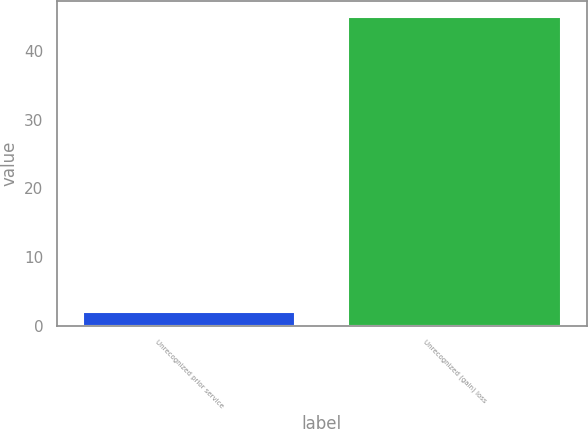Convert chart. <chart><loc_0><loc_0><loc_500><loc_500><bar_chart><fcel>Unrecognized prior service<fcel>Unrecognized (gain) loss<nl><fcel>2<fcel>45<nl></chart> 